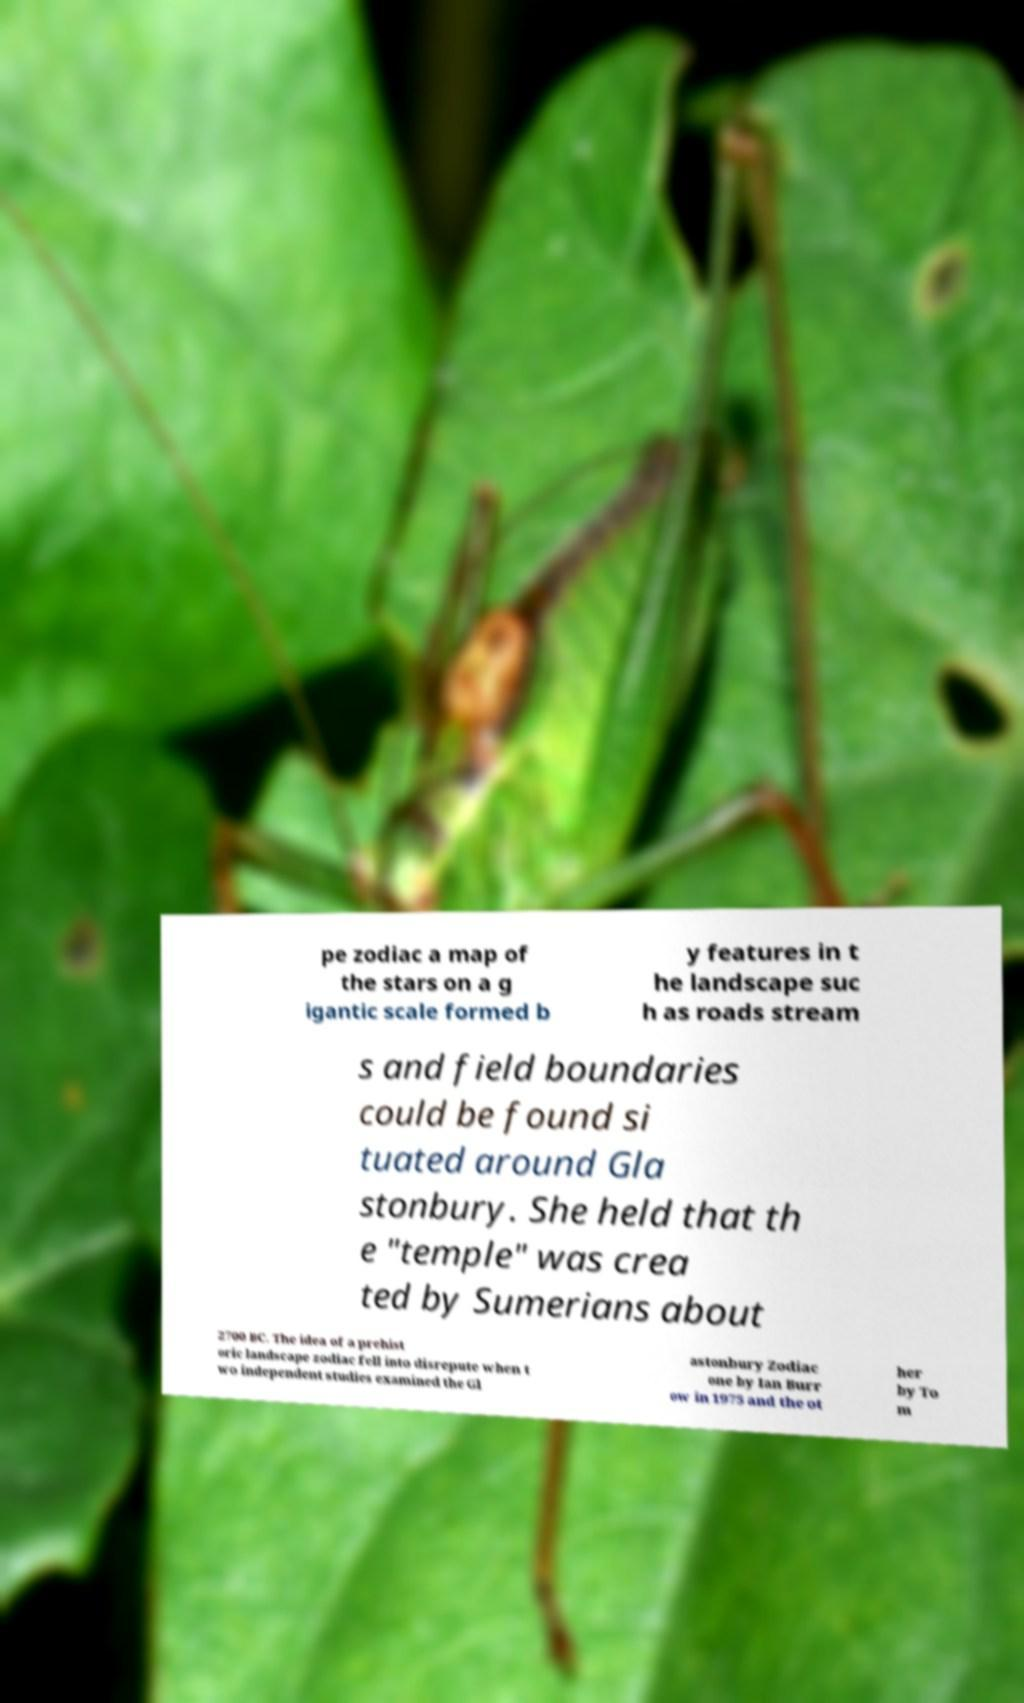Can you accurately transcribe the text from the provided image for me? pe zodiac a map of the stars on a g igantic scale formed b y features in t he landscape suc h as roads stream s and field boundaries could be found si tuated around Gla stonbury. She held that th e "temple" was crea ted by Sumerians about 2700 BC. The idea of a prehist oric landscape zodiac fell into disrepute when t wo independent studies examined the Gl astonbury Zodiac one by Ian Burr ow in 1975 and the ot her by To m 